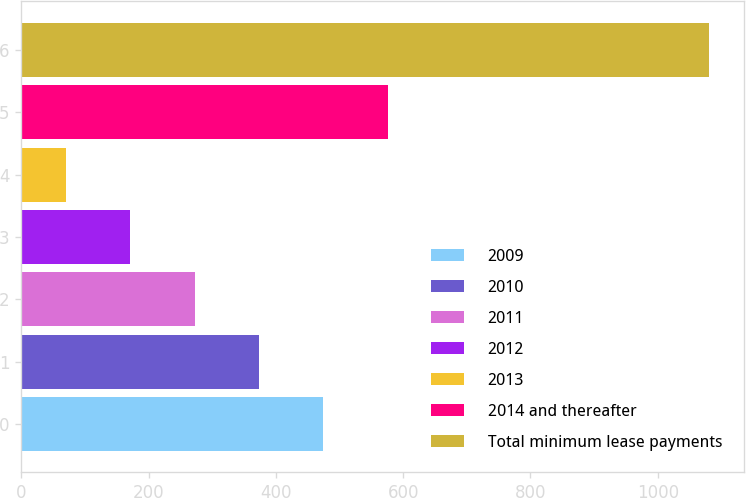Convert chart to OTSL. <chart><loc_0><loc_0><loc_500><loc_500><bar_chart><fcel>2009<fcel>2010<fcel>2011<fcel>2012<fcel>2013<fcel>2014 and thereafter<fcel>Total minimum lease payments<nl><fcel>474.4<fcel>373.3<fcel>272.2<fcel>171.1<fcel>70<fcel>575.5<fcel>1081<nl></chart> 